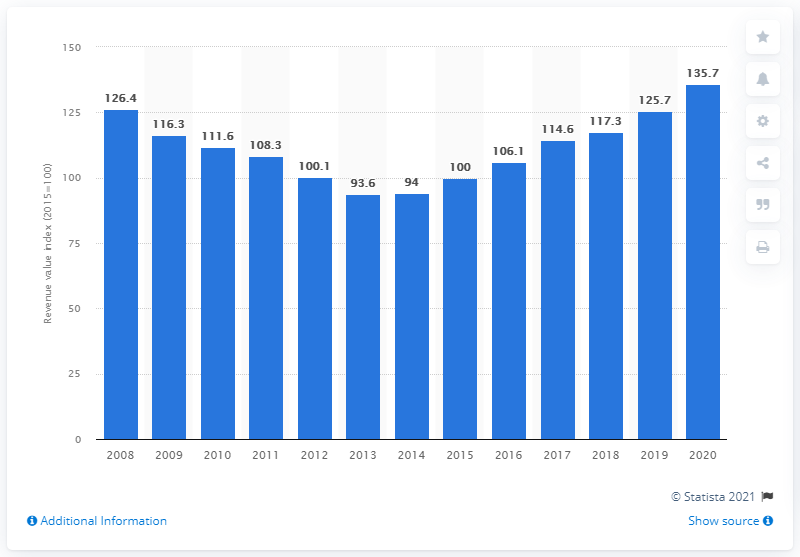List a handful of essential elements in this visual. In 2013, the revenue of Dutch furniture and home furnishing stores began to increase again. According to the value index of shops selling furniture and home furnishings in 2020, the value of these shops was 135.7. 